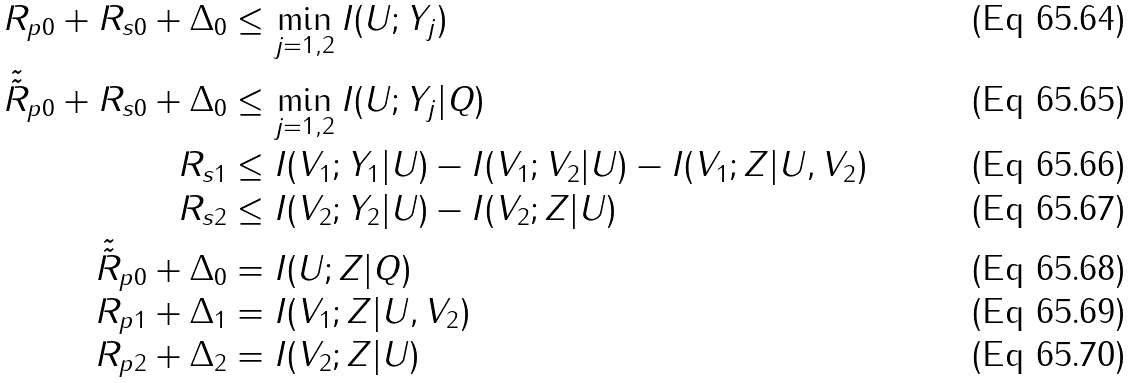<formula> <loc_0><loc_0><loc_500><loc_500>R _ { p 0 } + R _ { s 0 } + \Delta _ { 0 } & \leq \min _ { j = 1 , 2 } I ( U ; Y _ { j } ) \\ \tilde { \tilde { R } } _ { p 0 } + R _ { s 0 } + \Delta _ { 0 } & \leq \min _ { j = 1 , 2 } I ( U ; Y _ { j } | Q ) \\ R _ { s 1 } & \leq I ( V _ { 1 } ; Y _ { 1 } | U ) - I ( V _ { 1 } ; V _ { 2 } | U ) - I ( V _ { 1 } ; Z | U , V _ { 2 } ) \\ R _ { s 2 } & \leq I ( V _ { 2 } ; Y _ { 2 } | U ) - I ( V _ { 2 } ; Z | U ) \\ \tilde { \tilde { R } } _ { p 0 } + \Delta _ { 0 } & = I ( U ; Z | Q ) \\ R _ { p 1 } + \Delta _ { 1 } & = I ( V _ { 1 } ; Z | U , V _ { 2 } ) \\ R _ { p 2 } + \Delta _ { 2 } & = I ( V _ { 2 } ; Z | U )</formula> 